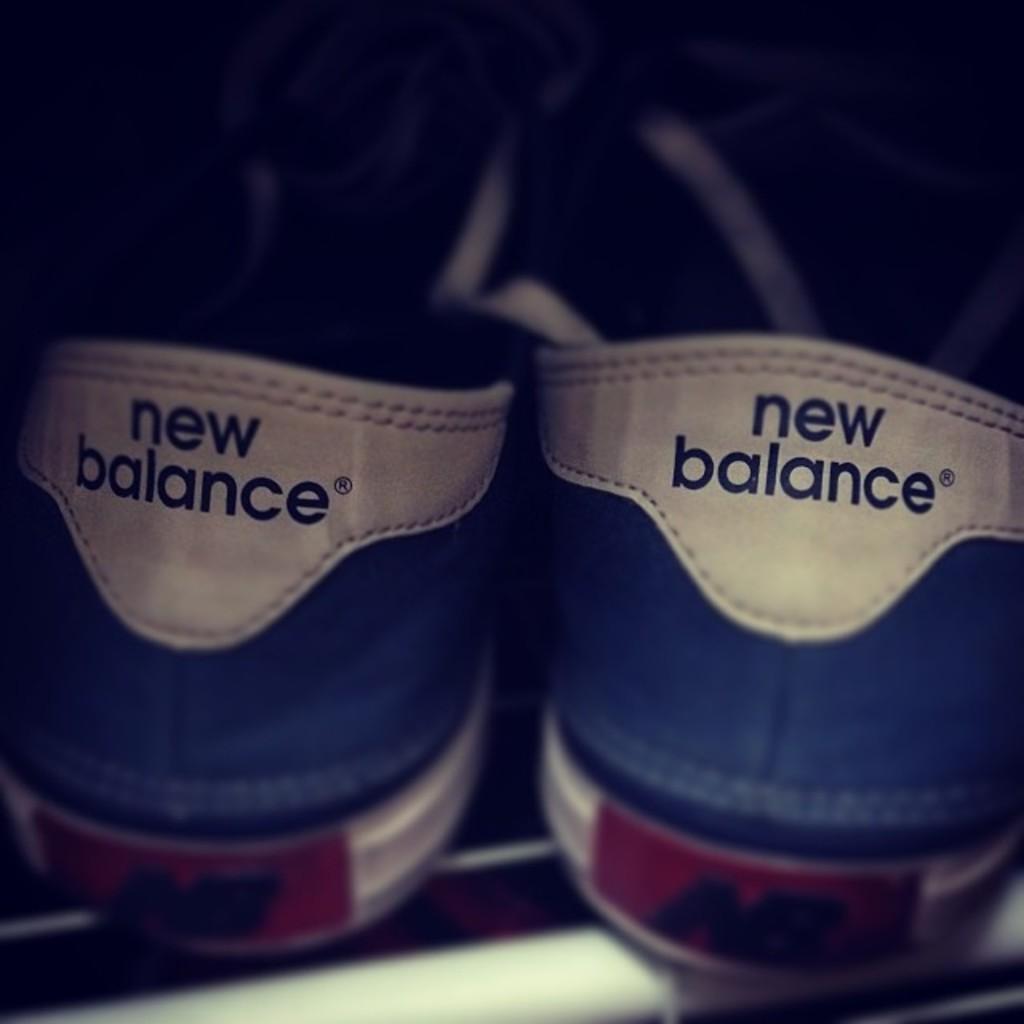Could you give a brief overview of what you see in this image? In this image we can see there is a pair of shoes in the middle. On the shoes there is some text. 